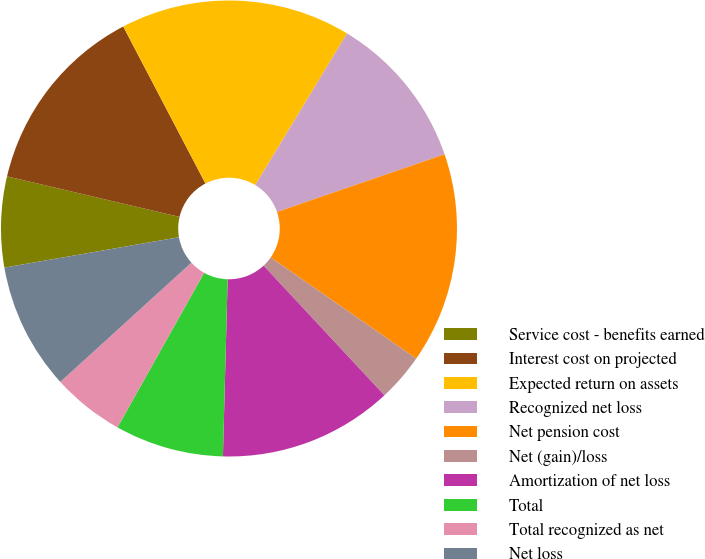Convert chart. <chart><loc_0><loc_0><loc_500><loc_500><pie_chart><fcel>Service cost - benefits earned<fcel>Interest cost on projected<fcel>Expected return on assets<fcel>Recognized net loss<fcel>Net pension cost<fcel>Net (gain)/loss<fcel>Amortization of net loss<fcel>Total<fcel>Total recognized as net<fcel>Net loss<nl><fcel>6.42%<fcel>13.65%<fcel>16.34%<fcel>11.06%<fcel>14.94%<fcel>3.4%<fcel>12.36%<fcel>7.71%<fcel>5.12%<fcel>9.0%<nl></chart> 